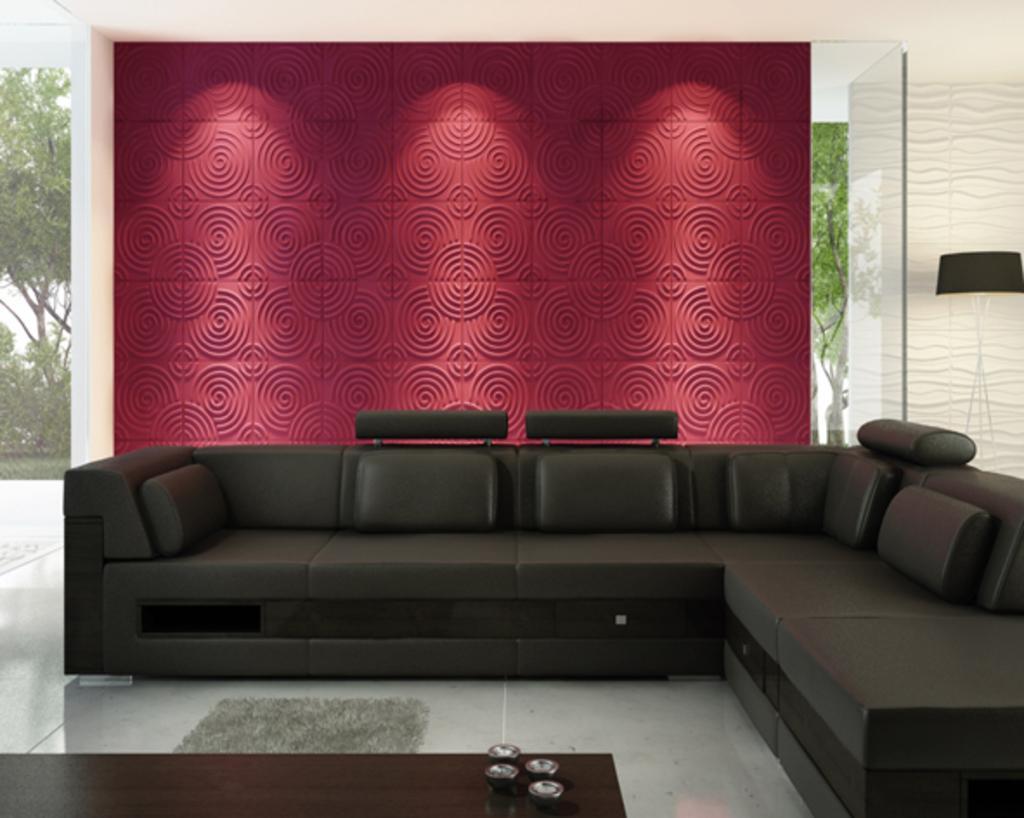Describe this image in one or two sentences. This picture is of inside. On the right corner we can see a lamp. In the center there is a couch, and a floor. In the background we can see a wall with wall art and in the left corner we can see the outside view consists of trees and plants. 